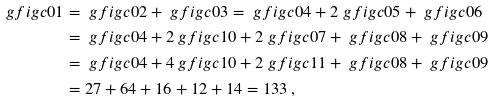Convert formula to latex. <formula><loc_0><loc_0><loc_500><loc_500>\ g f i g { c 0 1 } & = \ g f i g { c 0 2 } + \ g f i g { c 0 3 } = \ g f i g { c 0 4 } + 2 \ g f i g { c 0 5 } + \ g f i g { c 0 6 } \\ & = \ g f i g { c 0 4 } + 2 \ g f i g { c 1 0 } + 2 \ g f i g { c 0 7 } + \ g f i g { c 0 8 } + \ g f i g { c 0 9 } \\ & = \ g f i g { c 0 4 } + 4 \ g f i g { c 1 0 } + 2 \ g f i g { c 1 1 } + \ g f i g { c 0 8 } + \ g f i g { c 0 9 } \\ & = 2 7 + 6 4 + 1 6 + 1 2 + 1 4 = 1 3 3 \, ,</formula> 